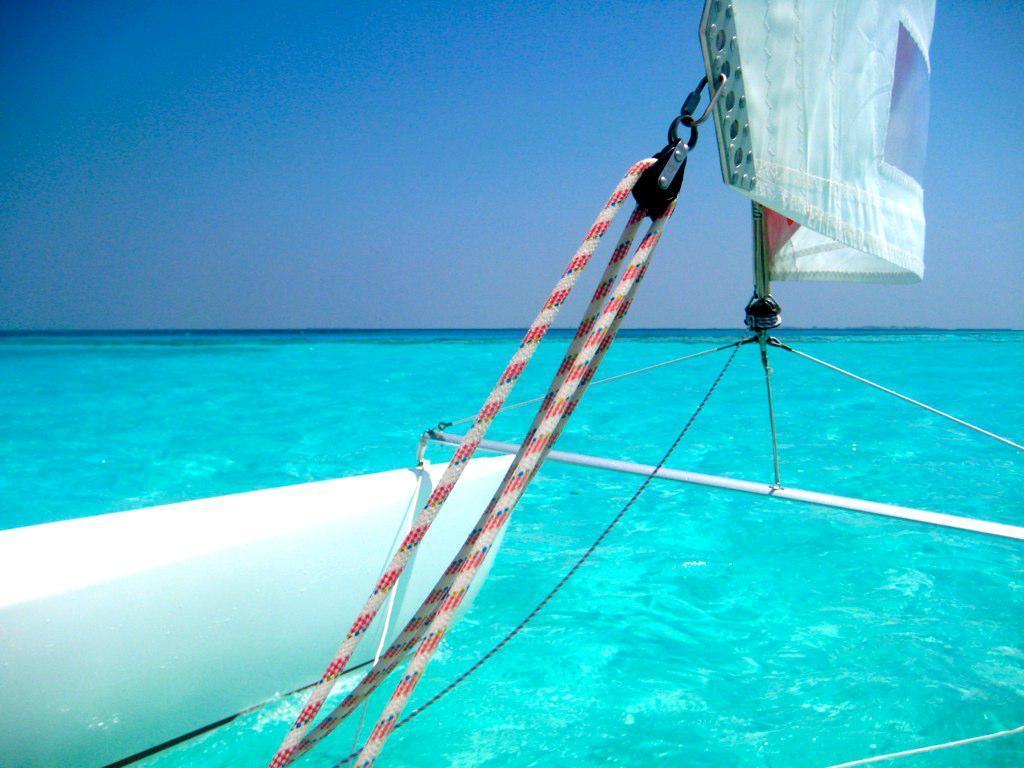Please provide a concise description of this image. In this image we can see truncated image of a boat in the water. At the top we can see the sky. 